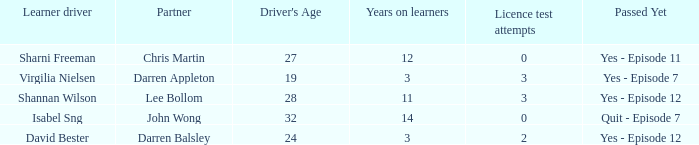What is the average number of years on learners of the drivers over the age of 24 with less than 0 attempts at the licence test? None. 